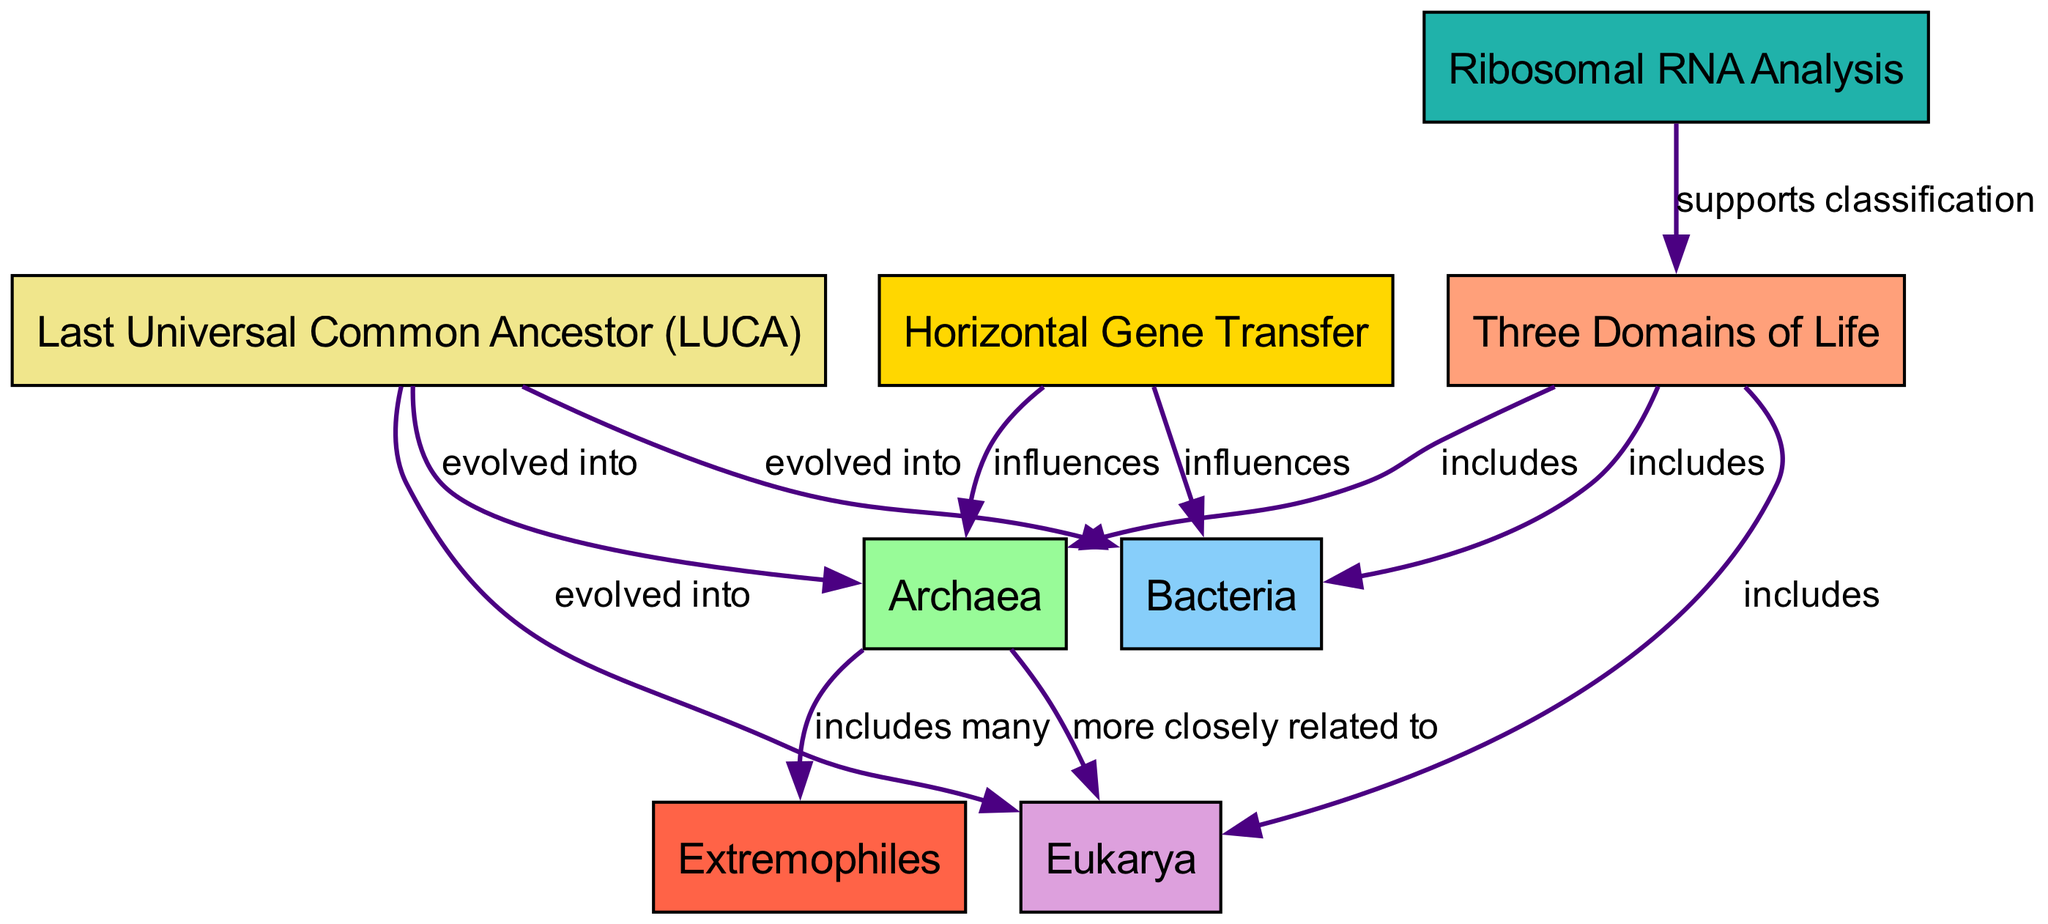What are the three domains of life depicted in the diagram? The diagram explicitly labels three domains of life: Archaea, Bacteria, and Eukarya, all of which are included under the node "Three Domains of Life."
Answer: Archaea, Bacteria, Eukarya How many nodes are present in the diagram? The diagram shows a total of eight nodes, as listed under the "nodes" section in the provided data, ranging from "Three Domains of Life" to "Extremophiles."
Answer: 8 What type of relationship is indicated between the Last Universal Common Ancestor and Archaea? The diagram shows the relationship labeled "evolved into" from the node "Last Universal Common Ancestor (LUCA)" to the node "Archaea," indicating that Archaea evolved from LUCA.
Answer: evolved into Which domain is indicated as more closely related to Archaea? The diagram has a directed edge labeled "more closely related to" that connects the node "Archaea" to the node "Eukarya," signifying that Archaea shares a closer evolutionary relationship with Eukarya than with Bacteria.
Answer: Eukarya What effect does Horizontal Gene Transfer have on Archaea according to the diagram? The diagram shows that Horizontal Gene Transfer influences Archaea, meaning that it impacts the genetic material or characteristics of Archaea, as indicated by the edge labeled "influences."
Answer: influences How does Ribosomal RNA Analysis contribute to the classification of the three domains? The diagram states that Ribosomal RNA Analysis supports the classification of the "Three Domains of Life," which indicates its role in providing evidence for differentiating between Archaea, Bacteria, and Eukarya based on ribosomal RNA data.
Answer: supports classification What kind of organisms does Archaea include? The diagram specifies that Archaea includes many Extremophiles, which are organisms that thrive in extreme environmental conditions.
Answer: Extremophiles How many edges connect the nodes in the diagram? By examining the edges listed in the "edges" section of the data, there are a total of eleven edges connecting various nodes, showcasing the relationships among the domains and other concepts.
Answer: 11 